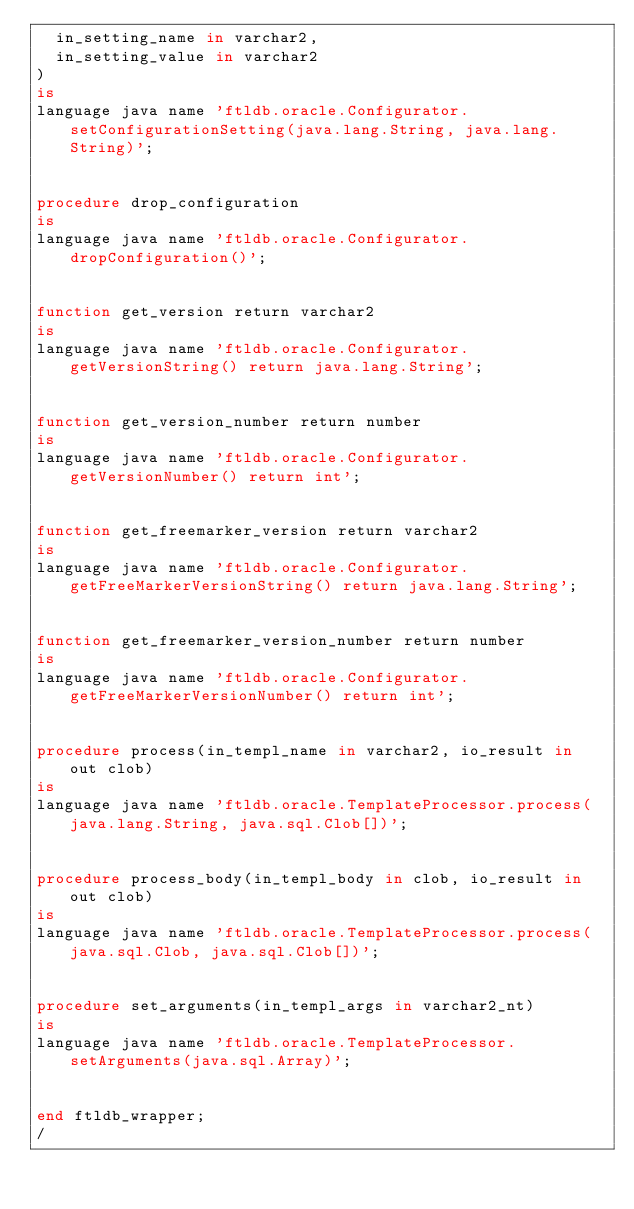<code> <loc_0><loc_0><loc_500><loc_500><_SQL_>  in_setting_name in varchar2,
  in_setting_value in varchar2
)
is
language java name 'ftldb.oracle.Configurator.setConfigurationSetting(java.lang.String, java.lang.String)';


procedure drop_configuration
is
language java name 'ftldb.oracle.Configurator.dropConfiguration()';


function get_version return varchar2
is
language java name 'ftldb.oracle.Configurator.getVersionString() return java.lang.String';


function get_version_number return number
is
language java name 'ftldb.oracle.Configurator.getVersionNumber() return int';


function get_freemarker_version return varchar2
is
language java name 'ftldb.oracle.Configurator.getFreeMarkerVersionString() return java.lang.String';


function get_freemarker_version_number return number
is
language java name 'ftldb.oracle.Configurator.getFreeMarkerVersionNumber() return int';


procedure process(in_templ_name in varchar2, io_result in out clob)
is
language java name 'ftldb.oracle.TemplateProcessor.process(java.lang.String, java.sql.Clob[])';


procedure process_body(in_templ_body in clob, io_result in out clob)
is
language java name 'ftldb.oracle.TemplateProcessor.process(java.sql.Clob, java.sql.Clob[])';


procedure set_arguments(in_templ_args in varchar2_nt)
is
language java name 'ftldb.oracle.TemplateProcessor.setArguments(java.sql.Array)';


end ftldb_wrapper;
/
</code> 